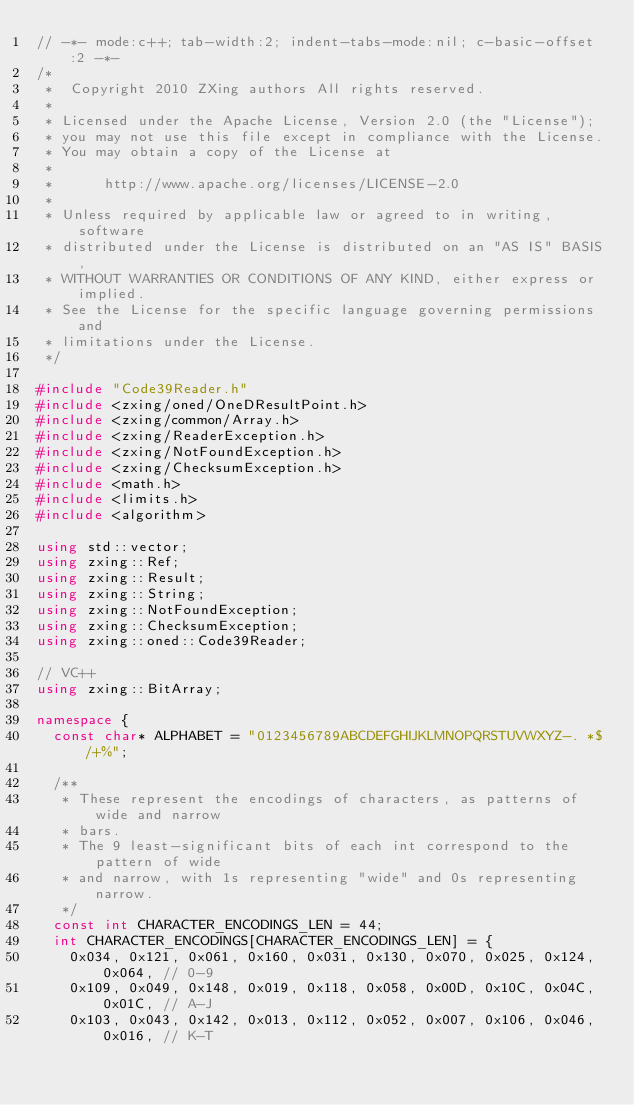<code> <loc_0><loc_0><loc_500><loc_500><_C++_>// -*- mode:c++; tab-width:2; indent-tabs-mode:nil; c-basic-offset:2 -*-
/*
 *  Copyright 2010 ZXing authors All rights reserved.
 *
 * Licensed under the Apache License, Version 2.0 (the "License");
 * you may not use this file except in compliance with the License.
 * You may obtain a copy of the License at
 *
 *      http://www.apache.org/licenses/LICENSE-2.0
 *
 * Unless required by applicable law or agreed to in writing, software
 * distributed under the License is distributed on an "AS IS" BASIS,
 * WITHOUT WARRANTIES OR CONDITIONS OF ANY KIND, either express or implied.
 * See the License for the specific language governing permissions and
 * limitations under the License.
 */

#include "Code39Reader.h"
#include <zxing/oned/OneDResultPoint.h>
#include <zxing/common/Array.h>
#include <zxing/ReaderException.h>
#include <zxing/NotFoundException.h>
#include <zxing/ChecksumException.h>
#include <math.h>
#include <limits.h>
#include <algorithm>

using std::vector;
using zxing::Ref;
using zxing::Result;
using zxing::String;
using zxing::NotFoundException;
using zxing::ChecksumException;
using zxing::oned::Code39Reader;

// VC++
using zxing::BitArray;

namespace {
  const char* ALPHABET = "0123456789ABCDEFGHIJKLMNOPQRSTUVWXYZ-. *$/+%";

  /**
   * These represent the encodings of characters, as patterns of wide and narrow
   * bars.
   * The 9 least-significant bits of each int correspond to the pattern of wide
   * and narrow, with 1s representing "wide" and 0s representing narrow.
   */
  const int CHARACTER_ENCODINGS_LEN = 44;
  int CHARACTER_ENCODINGS[CHARACTER_ENCODINGS_LEN] = {
    0x034, 0x121, 0x061, 0x160, 0x031, 0x130, 0x070, 0x025, 0x124, 0x064, // 0-9
    0x109, 0x049, 0x148, 0x019, 0x118, 0x058, 0x00D, 0x10C, 0x04C, 0x01C, // A-J
    0x103, 0x043, 0x142, 0x013, 0x112, 0x052, 0x007, 0x106, 0x046, 0x016, // K-T</code> 